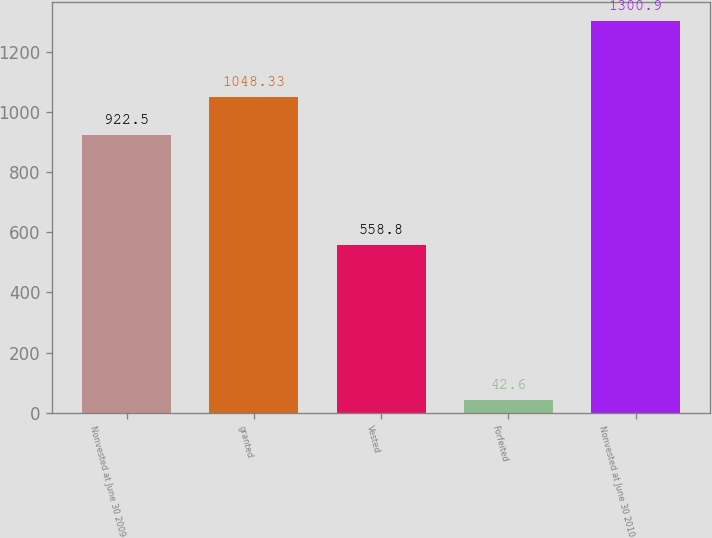Convert chart to OTSL. <chart><loc_0><loc_0><loc_500><loc_500><bar_chart><fcel>Nonvested at June 30 2009<fcel>granted<fcel>Vested<fcel>Forfeited<fcel>Nonvested at June 30 2010<nl><fcel>922.5<fcel>1048.33<fcel>558.8<fcel>42.6<fcel>1300.9<nl></chart> 